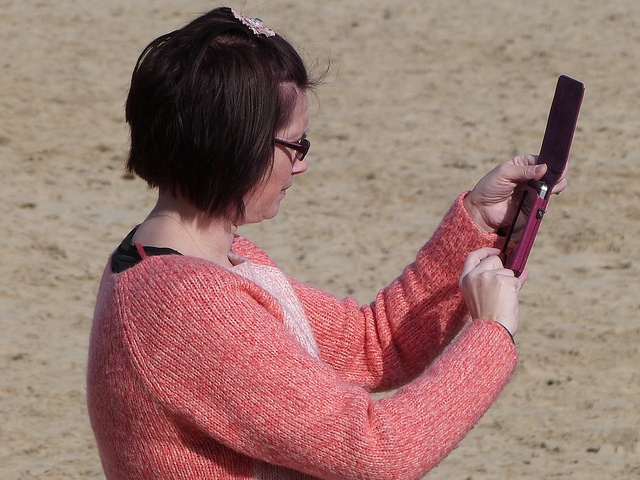Describe the objects in this image and their specific colors. I can see people in darkgray, black, brown, lightpink, and maroon tones and cell phone in darkgray, black, maroon, and purple tones in this image. 